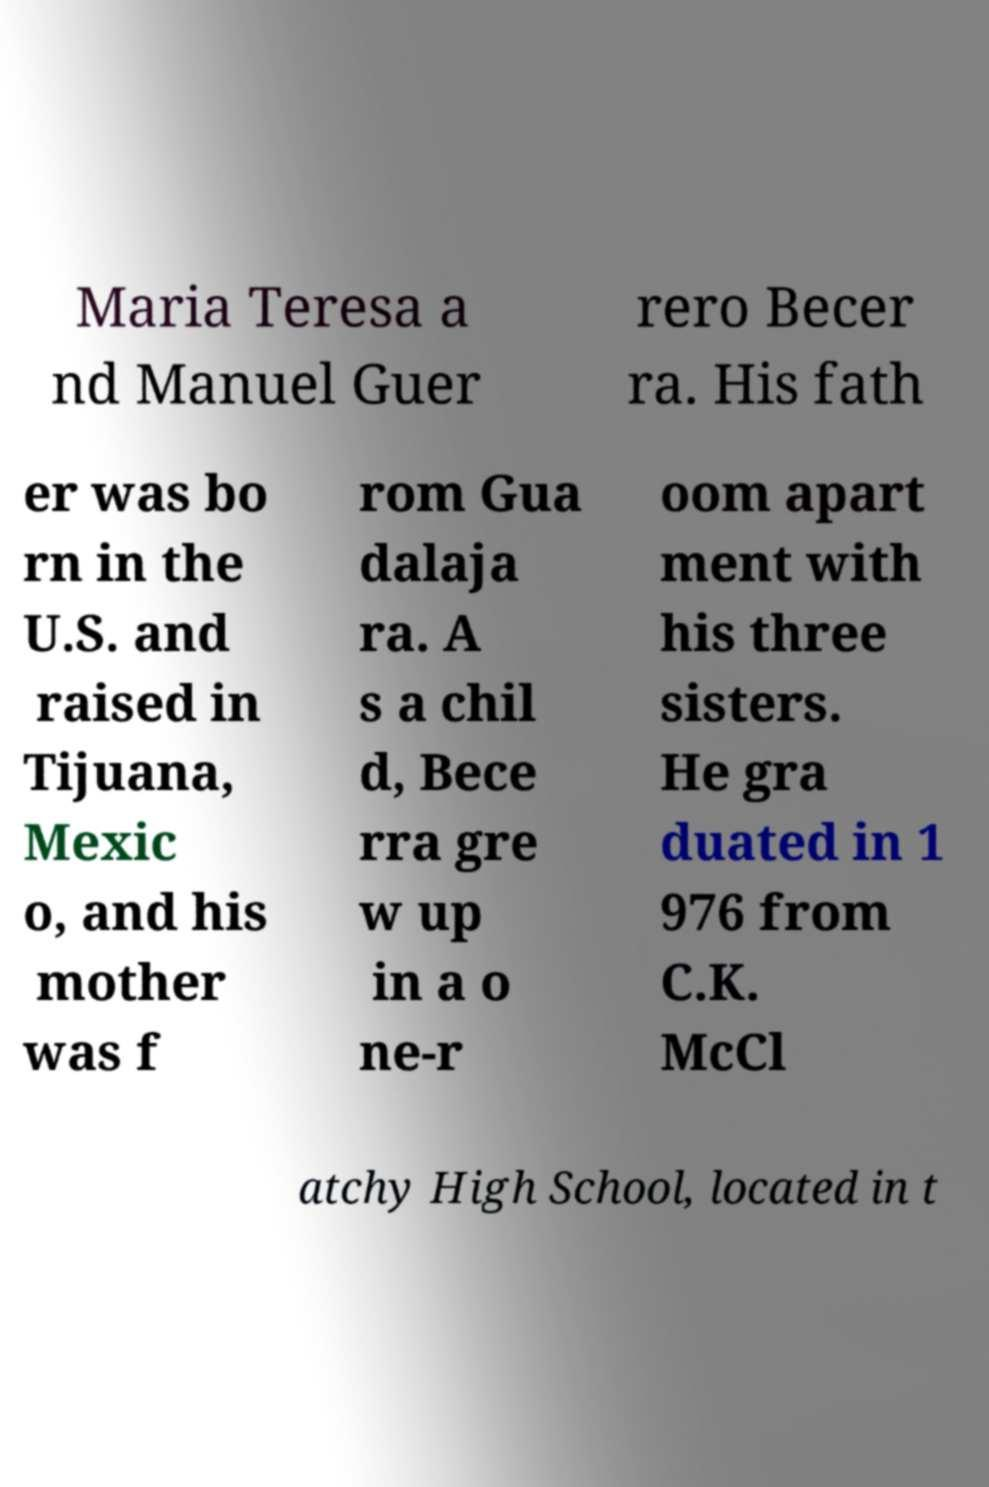There's text embedded in this image that I need extracted. Can you transcribe it verbatim? Maria Teresa a nd Manuel Guer rero Becer ra. His fath er was bo rn in the U.S. and raised in Tijuana, Mexic o, and his mother was f rom Gua dalaja ra. A s a chil d, Bece rra gre w up in a o ne-r oom apart ment with his three sisters. He gra duated in 1 976 from C.K. McCl atchy High School, located in t 